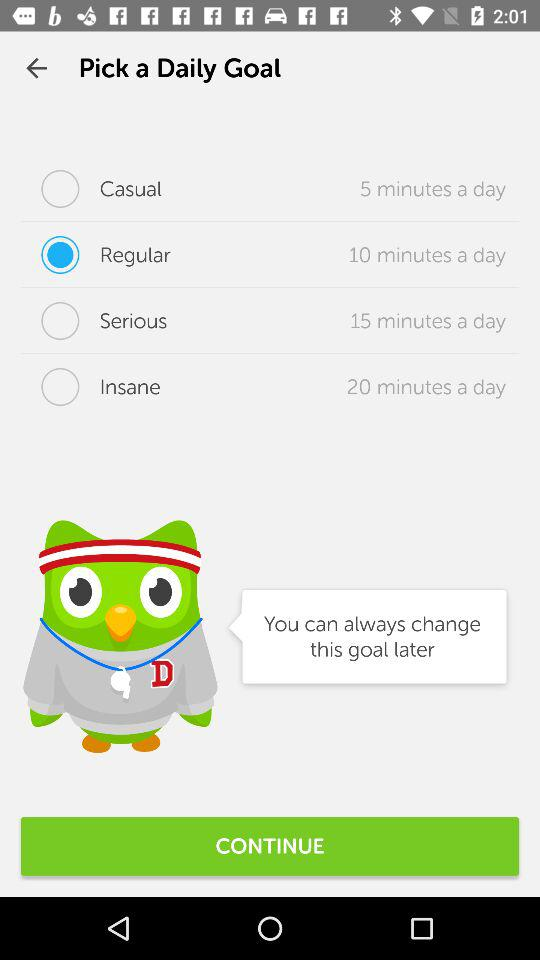What's the selected "Daily Goal" option? The selected "Daily Goal" option is "Regular". 